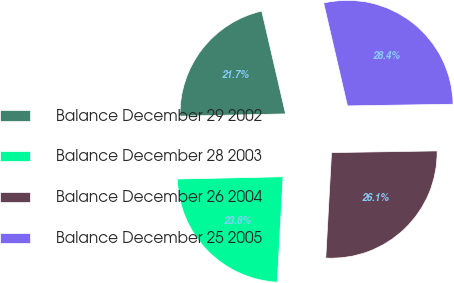Convert chart to OTSL. <chart><loc_0><loc_0><loc_500><loc_500><pie_chart><fcel>Balance December 29 2002<fcel>Balance December 28 2003<fcel>Balance December 26 2004<fcel>Balance December 25 2005<nl><fcel>21.72%<fcel>23.79%<fcel>26.12%<fcel>28.37%<nl></chart> 